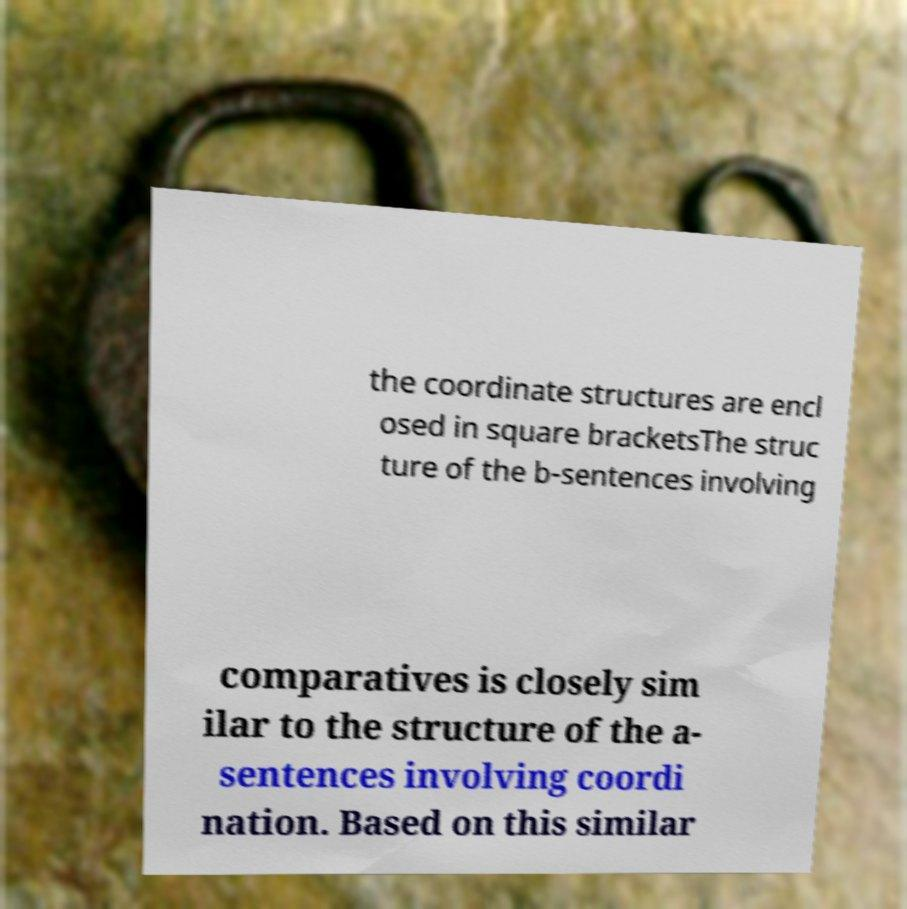Please identify and transcribe the text found in this image. the coordinate structures are encl osed in square bracketsThe struc ture of the b-sentences involving comparatives is closely sim ilar to the structure of the a- sentences involving coordi nation. Based on this similar 